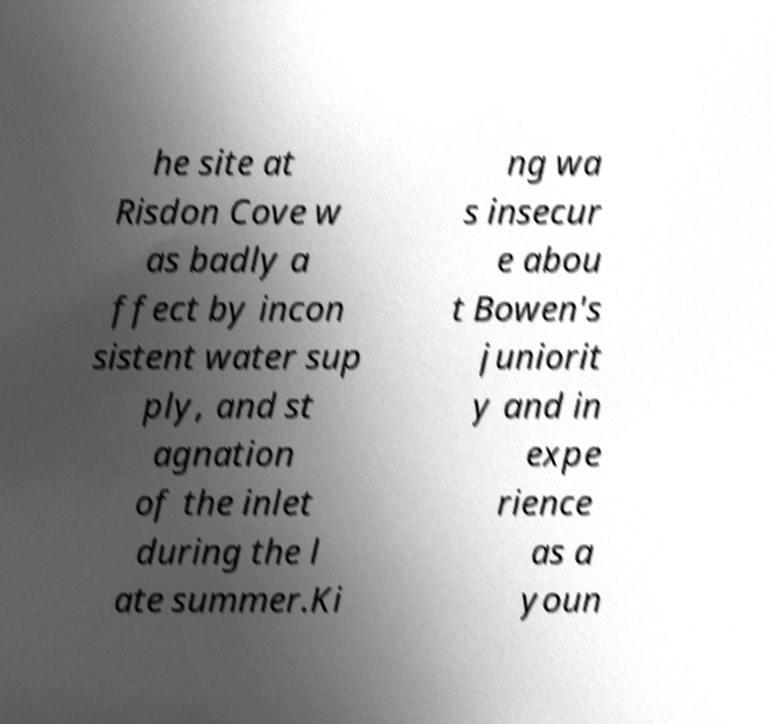Could you extract and type out the text from this image? he site at Risdon Cove w as badly a ffect by incon sistent water sup ply, and st agnation of the inlet during the l ate summer.Ki ng wa s insecur e abou t Bowen's juniorit y and in expe rience as a youn 